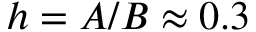<formula> <loc_0><loc_0><loc_500><loc_500>h = A / B \approx 0 . 3</formula> 